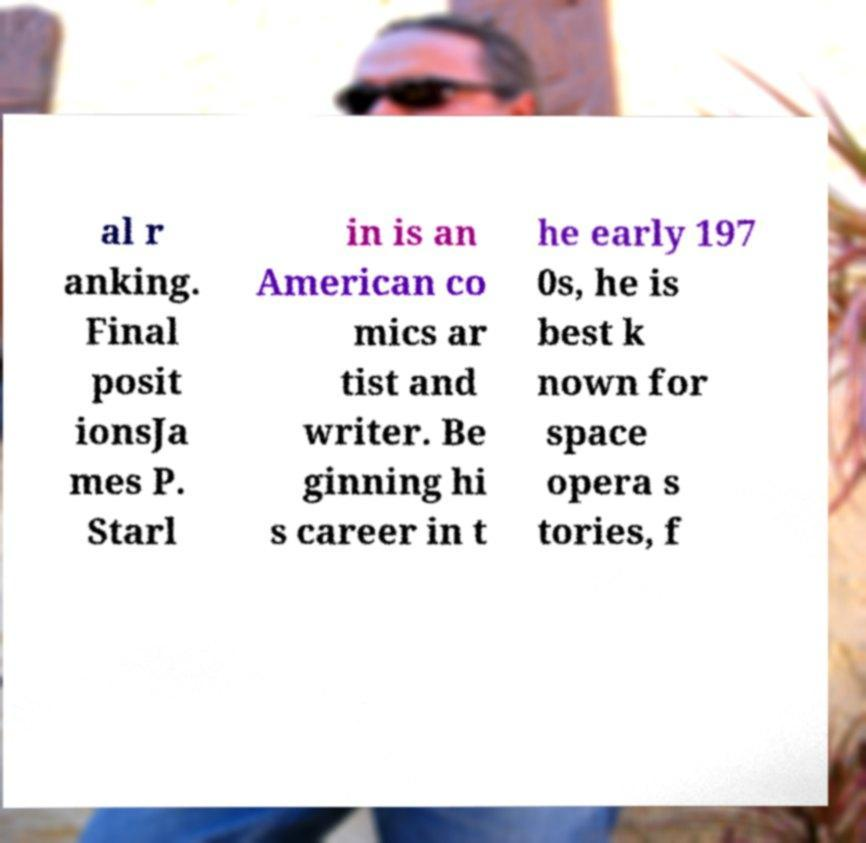Can you accurately transcribe the text from the provided image for me? al r anking. Final posit ionsJa mes P. Starl in is an American co mics ar tist and writer. Be ginning hi s career in t he early 197 0s, he is best k nown for space opera s tories, f 